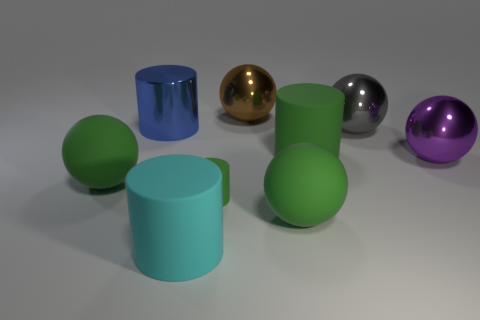Subtract all large cylinders. How many cylinders are left? 1 Subtract 4 cylinders. How many cylinders are left? 0 Subtract all spheres. How many objects are left? 4 Subtract all cyan cylinders. How many cylinders are left? 3 Subtract all yellow balls. Subtract all red cylinders. How many balls are left? 5 Subtract all blue cubes. How many purple cylinders are left? 0 Subtract all cyan rubber objects. Subtract all cyan objects. How many objects are left? 7 Add 3 rubber cylinders. How many rubber cylinders are left? 6 Add 1 yellow rubber cylinders. How many yellow rubber cylinders exist? 1 Subtract 0 gray cylinders. How many objects are left? 9 